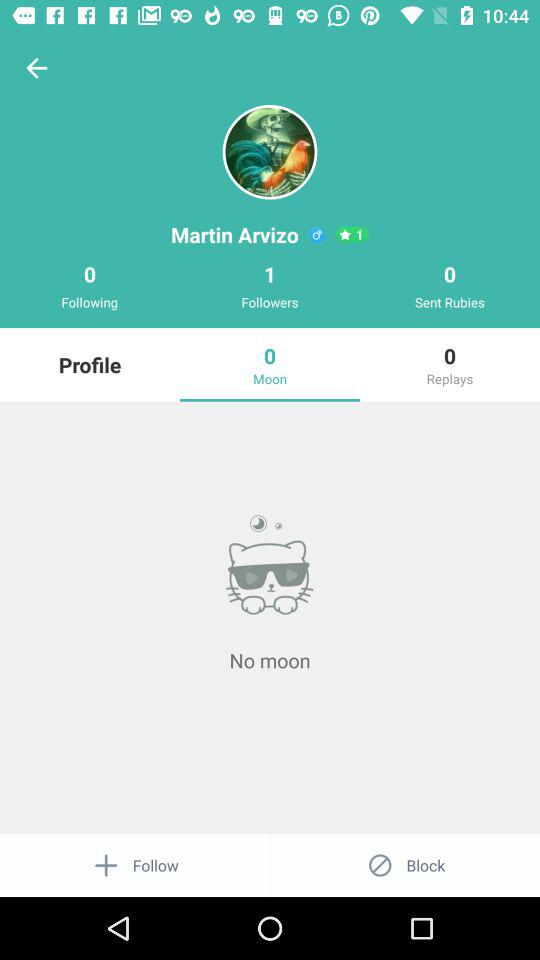What is the number of followers on the screenshot? The number of followers is 1. 